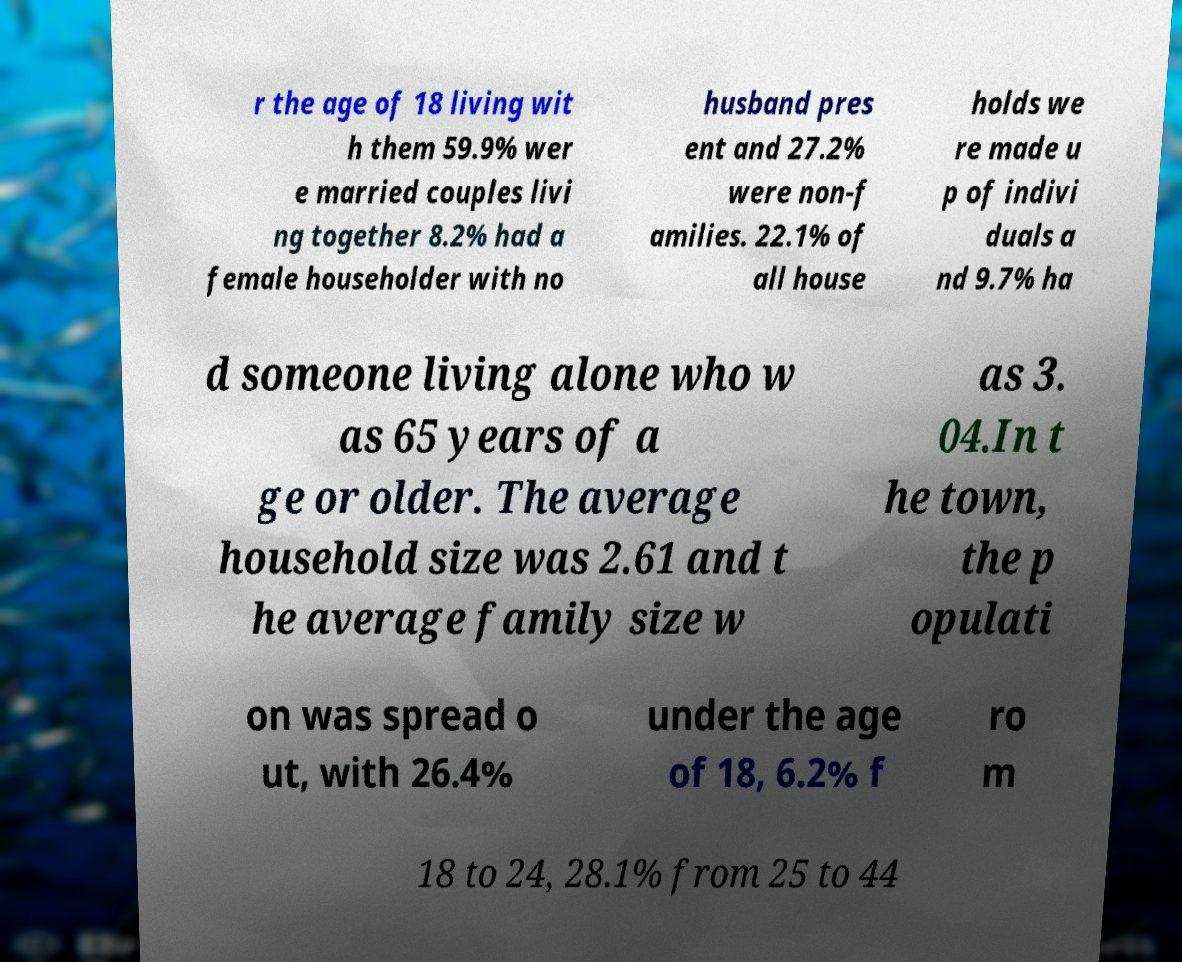There's text embedded in this image that I need extracted. Can you transcribe it verbatim? r the age of 18 living wit h them 59.9% wer e married couples livi ng together 8.2% had a female householder with no husband pres ent and 27.2% were non-f amilies. 22.1% of all house holds we re made u p of indivi duals a nd 9.7% ha d someone living alone who w as 65 years of a ge or older. The average household size was 2.61 and t he average family size w as 3. 04.In t he town, the p opulati on was spread o ut, with 26.4% under the age of 18, 6.2% f ro m 18 to 24, 28.1% from 25 to 44 